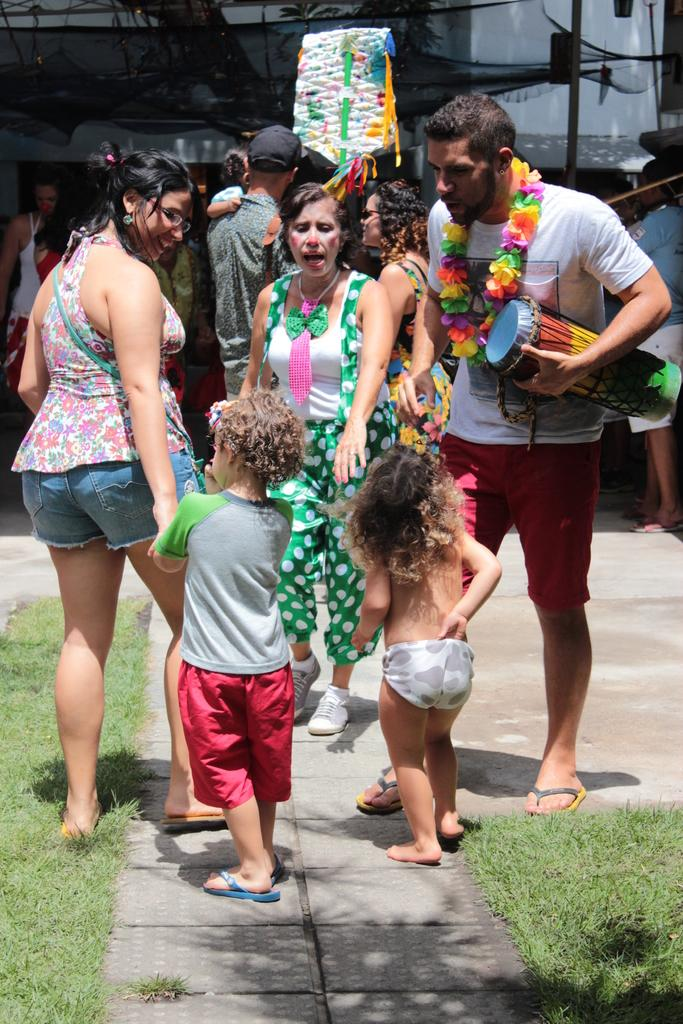What is in the foreground of the picture? There are kids, women, a man holding a tabla, grass, and a payment in the foreground of the picture. Can you describe the people in the foreground? There are kids and women in the foreground, and a man is holding a tabla. What is the weather like in the image? It is sunny in the image. What can be seen in the background of the picture? There are people, trees, a net, and a building in the background of the picture. What type of jeans is the man wearing in the image? There is no mention of jeans in the image; the man is holding a tabla. Can you describe the sink in the image? There is no sink present in the image. 